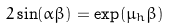<formula> <loc_0><loc_0><loc_500><loc_500>2 \sin ( \alpha \beta ) = \exp ( \mu _ { h } \beta )</formula> 